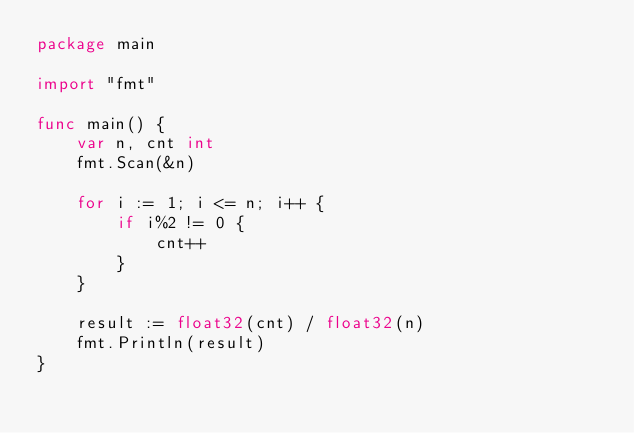<code> <loc_0><loc_0><loc_500><loc_500><_Go_>package main

import "fmt"

func main() {
	var n, cnt int
	fmt.Scan(&n)

	for i := 1; i <= n; i++ {
		if i%2 != 0 {
			cnt++
		}
	}

	result := float32(cnt) / float32(n)
	fmt.Println(result)
}
</code> 